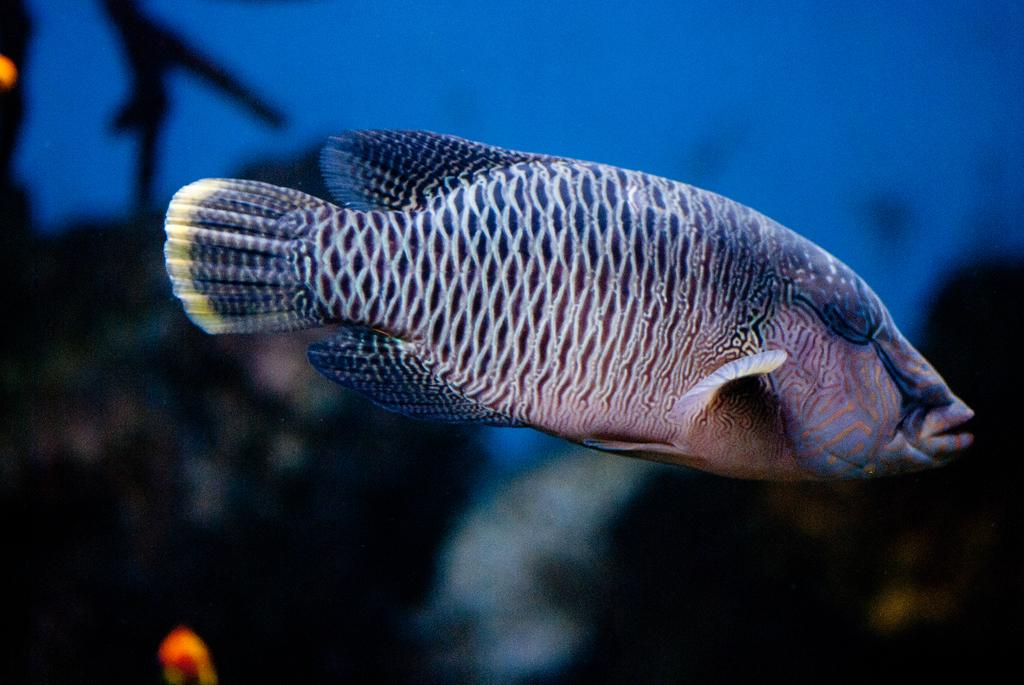What is the main subject of the image? The main subject of the image is a fish. Where is the fish located in the image? The fish is in the center of the image. Can you describe the appearance of the fish? The fish has different colors and patterns. What type of expert is providing advice in the image? There is no expert present in the image; it features a fish with different colors and patterns. What key is used to unlock the door in the image? There is no door or key present in the image; it features a fish. 